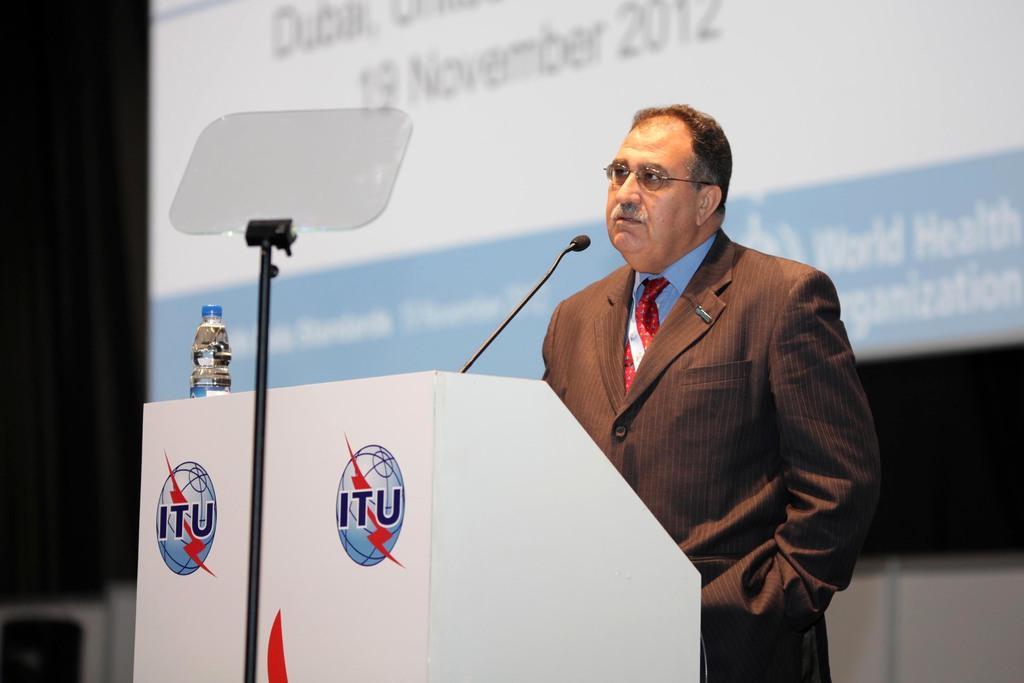In one or two sentences, can you explain what this image depicts? In this image I can see a person is standing on the stage in front of a table and mike. In the background I can see a screen and dark color. This image is taken may be in a hall. 